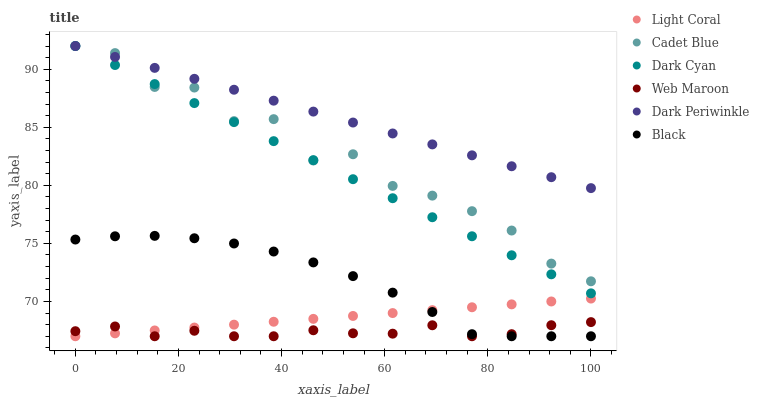Does Web Maroon have the minimum area under the curve?
Answer yes or no. Yes. Does Dark Periwinkle have the maximum area under the curve?
Answer yes or no. Yes. Does Light Coral have the minimum area under the curve?
Answer yes or no. No. Does Light Coral have the maximum area under the curve?
Answer yes or no. No. Is Light Coral the smoothest?
Answer yes or no. Yes. Is Cadet Blue the roughest?
Answer yes or no. Yes. Is Web Maroon the smoothest?
Answer yes or no. No. Is Web Maroon the roughest?
Answer yes or no. No. Does Web Maroon have the lowest value?
Answer yes or no. Yes. Does Dark Cyan have the lowest value?
Answer yes or no. No. Does Dark Periwinkle have the highest value?
Answer yes or no. Yes. Does Light Coral have the highest value?
Answer yes or no. No. Is Web Maroon less than Dark Cyan?
Answer yes or no. Yes. Is Dark Cyan greater than Light Coral?
Answer yes or no. Yes. Does Cadet Blue intersect Dark Periwinkle?
Answer yes or no. Yes. Is Cadet Blue less than Dark Periwinkle?
Answer yes or no. No. Is Cadet Blue greater than Dark Periwinkle?
Answer yes or no. No. Does Web Maroon intersect Dark Cyan?
Answer yes or no. No. 